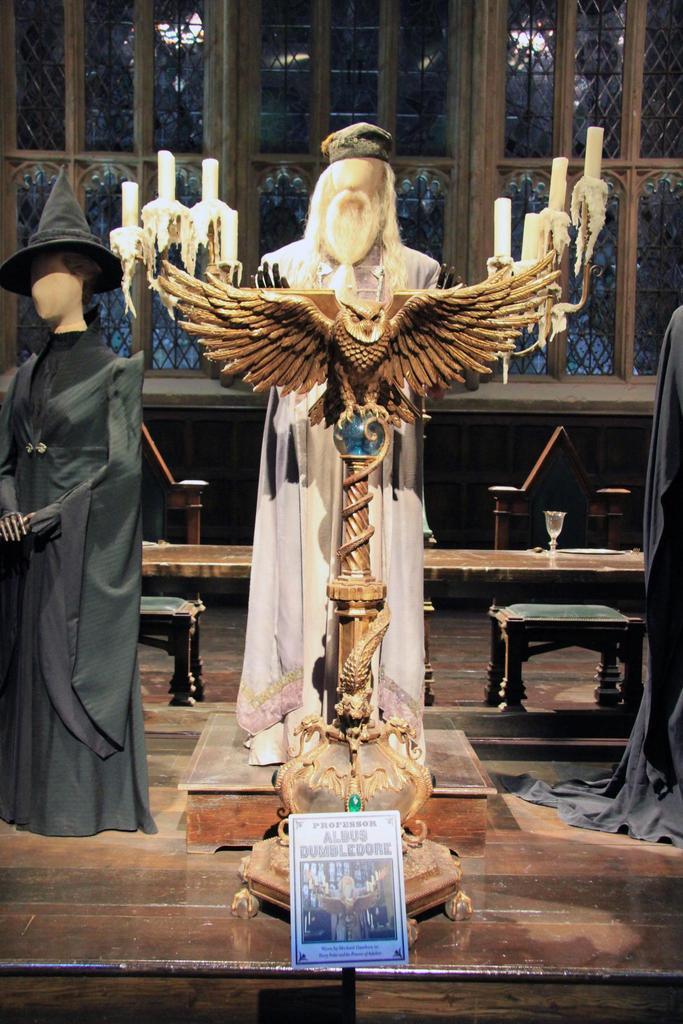In one or two sentences, can you explain what this image depicts? In the foreground of this image, there is a statue and a candle holder and a book holder is in front of him. On the other side, there are two statues. In the background, there is a table, glasses, chairs and the glass wall. 